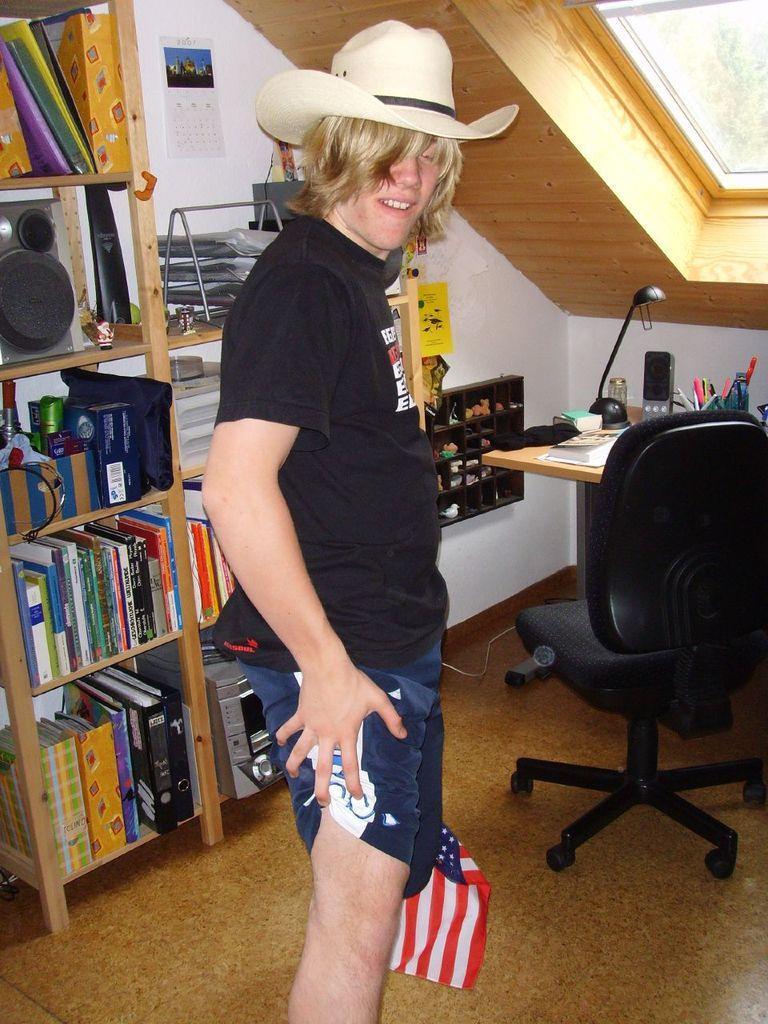In one or two sentences, can you explain what this image depicts? This picture is clicked inside the room. Here, we see a man in black t-shirt who is wearing white hat is standing and holding flag in his hands. Behind him, we see bunch of books in the rack and even speakers. Beside that, we see a wall which is white in color and a calendar is placed on the wall. On the right top of the picture, we see a window and the right middle of picture, we see table on which mobile phone,pen, book is placed. We even see a chair beside the table. 